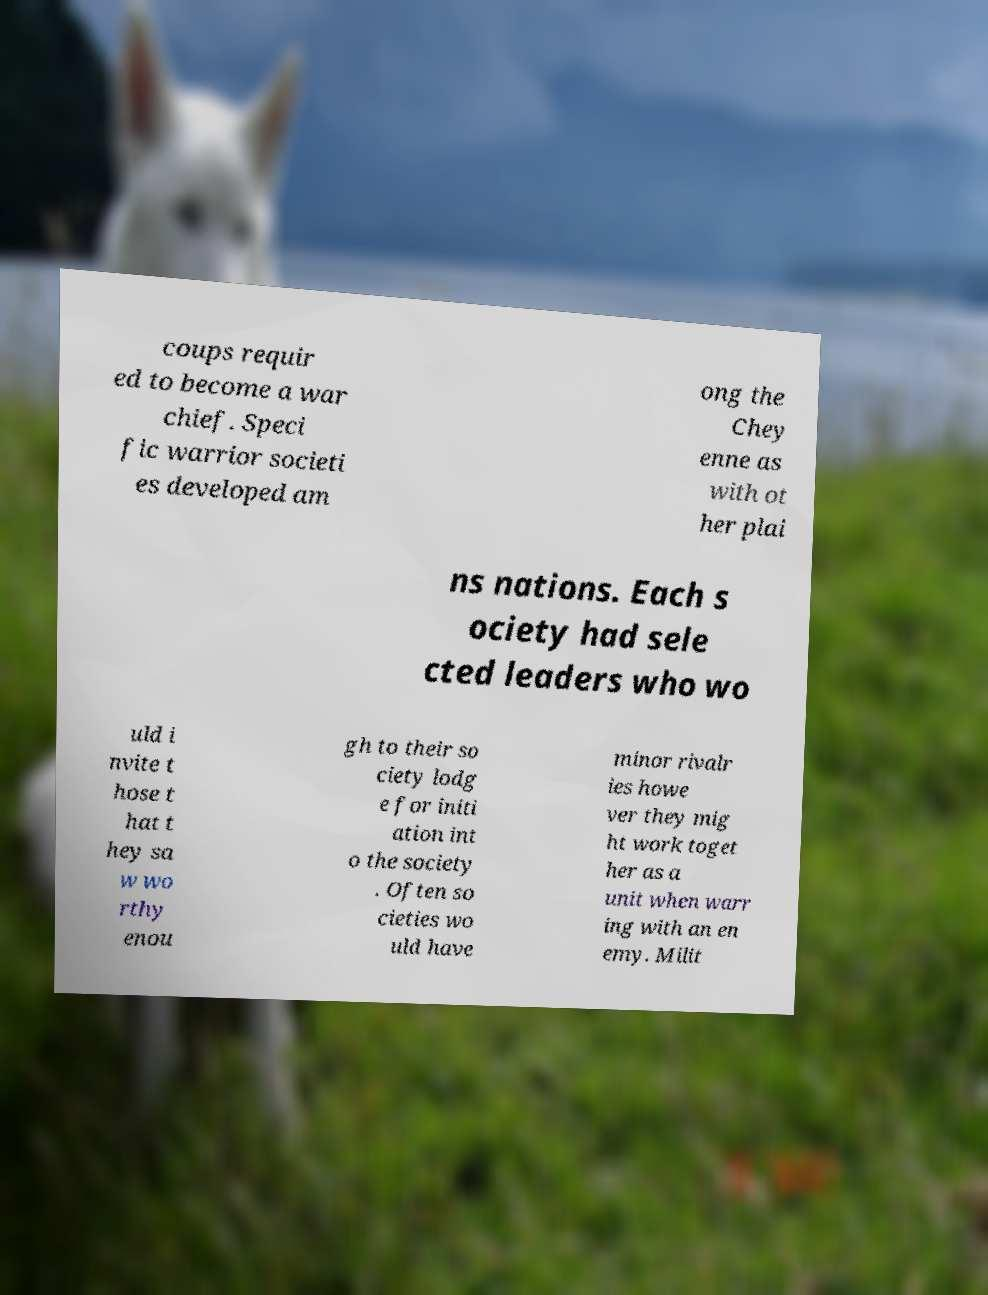Could you assist in decoding the text presented in this image and type it out clearly? coups requir ed to become a war chief. Speci fic warrior societi es developed am ong the Chey enne as with ot her plai ns nations. Each s ociety had sele cted leaders who wo uld i nvite t hose t hat t hey sa w wo rthy enou gh to their so ciety lodg e for initi ation int o the society . Often so cieties wo uld have minor rivalr ies howe ver they mig ht work toget her as a unit when warr ing with an en emy. Milit 